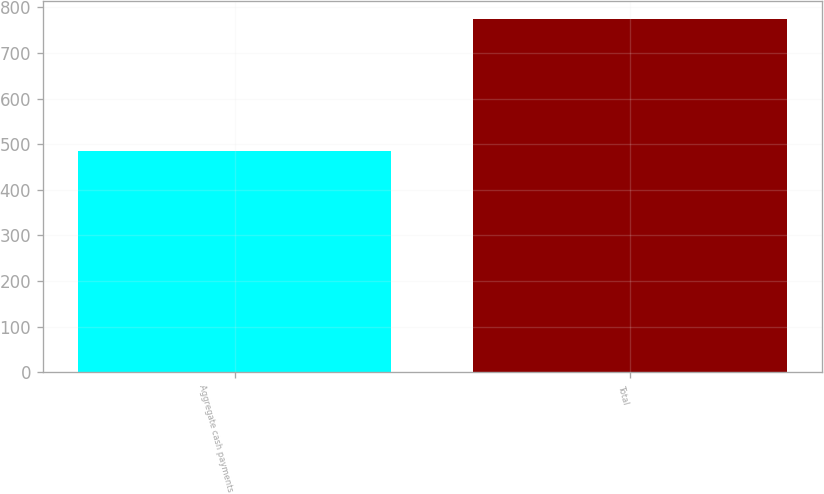Convert chart. <chart><loc_0><loc_0><loc_500><loc_500><bar_chart><fcel>Aggregate cash payments<fcel>Total<nl><fcel>485<fcel>775<nl></chart> 